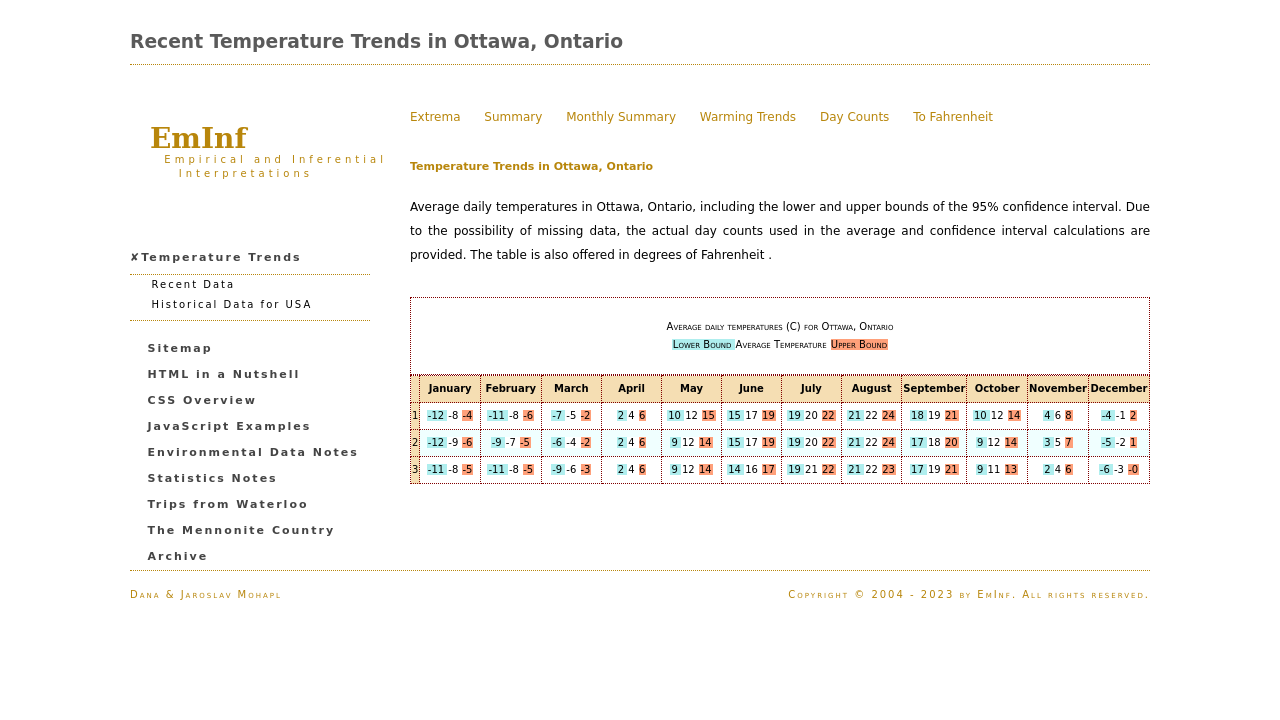What tools would be necessary to implement the dynamic features shown in the website, like switching between Celsius and Fahrenheit? To implement dynamic features such as switching between Celsius and Fahrenheit, you would need JavaScript or a similar scripting language. This will allow you to manipulate the DOM and change the content dynamically based on user interaction. Adding event listeners to the buttons or switches for changing units will trigger functions that convert the values and update the display accordingly. Could you provide a simple example of such a JavaScript function? Sure! Here's a basic example:

function toggleTemperatureUnit(values, currentUnit) {
  return values.map(value => {
    if(currentUnit === 'C') {
      return (value * 9/5) + 32; // Convert Celsius to Fahrenheit
    } else {
      return (value - 32) * 5/9; // Convert Fahrenheit to Celsius
    }
  });
}

This function takes an array of temperature values and the current unit, converts each temperature to the opposite unit, and returns the new values. 